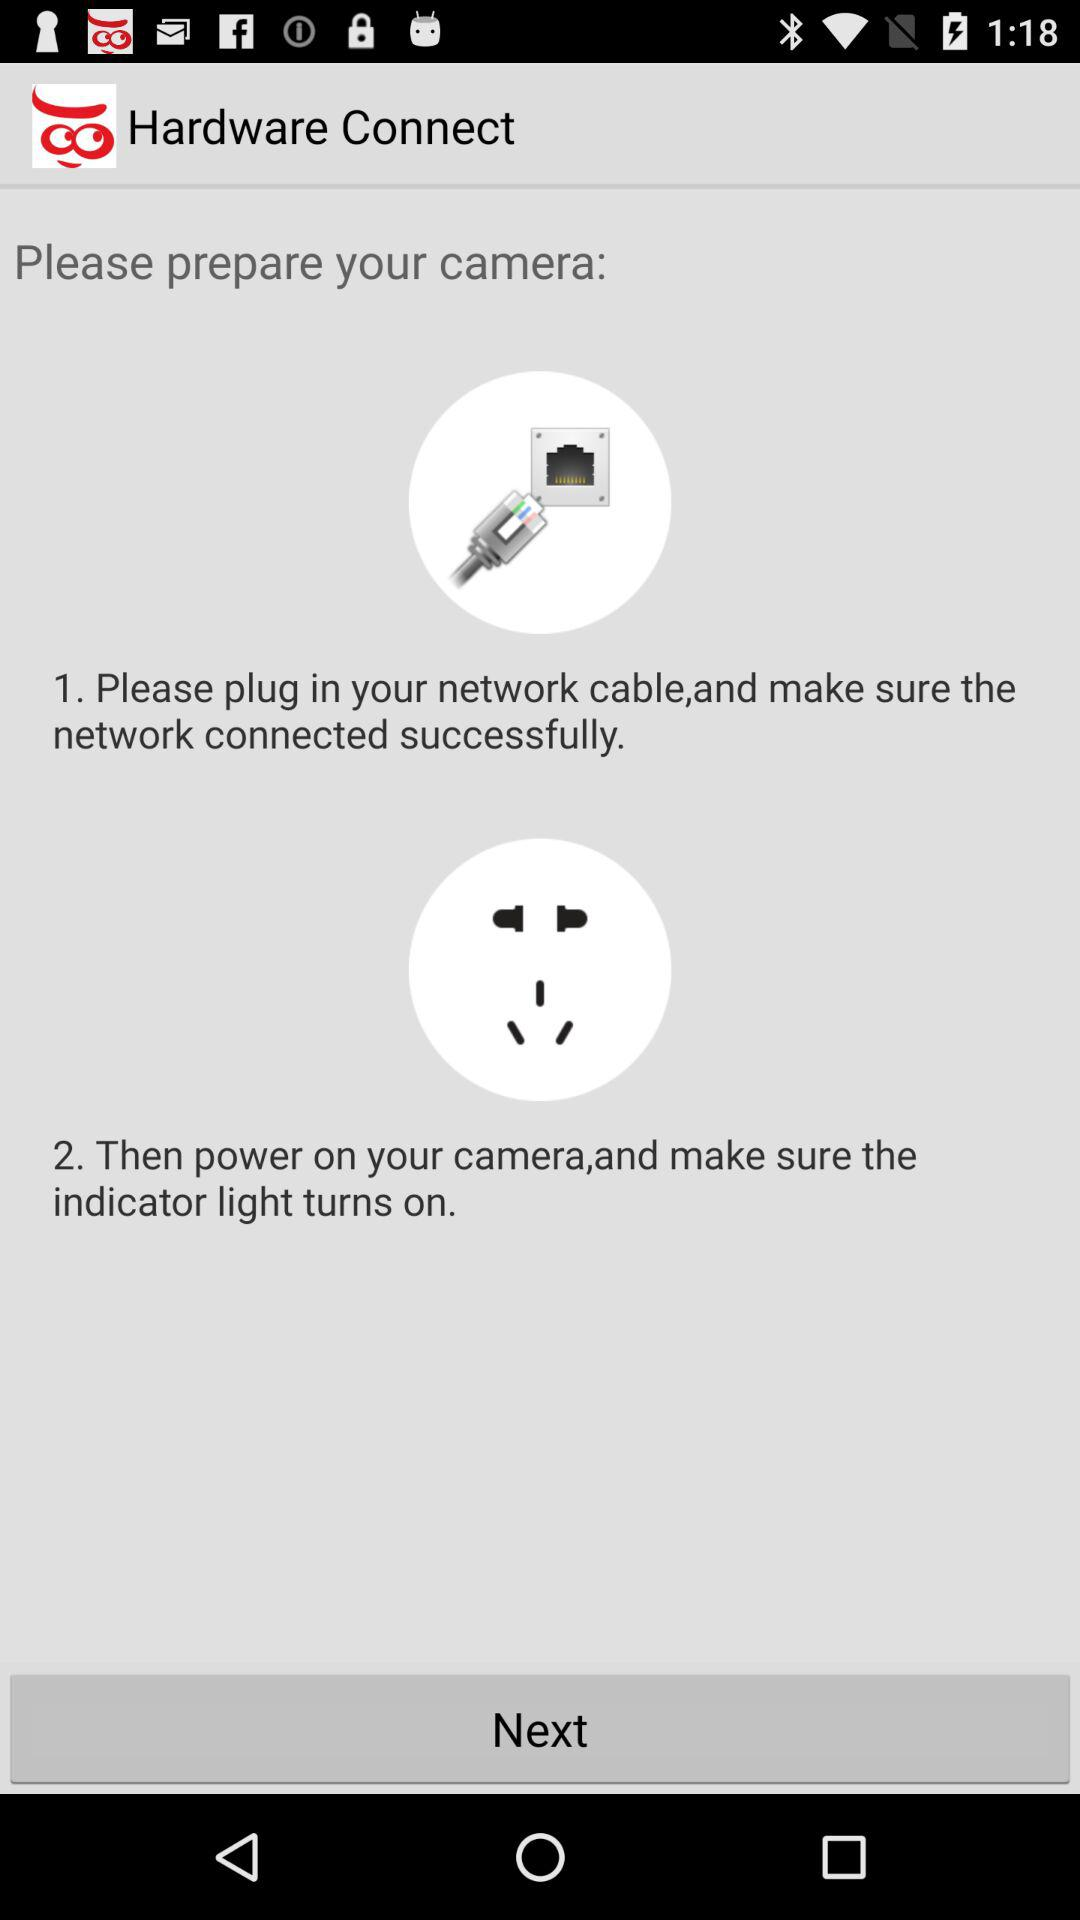How many steps are there in the process of preparing the camera?
Answer the question using a single word or phrase. 2 